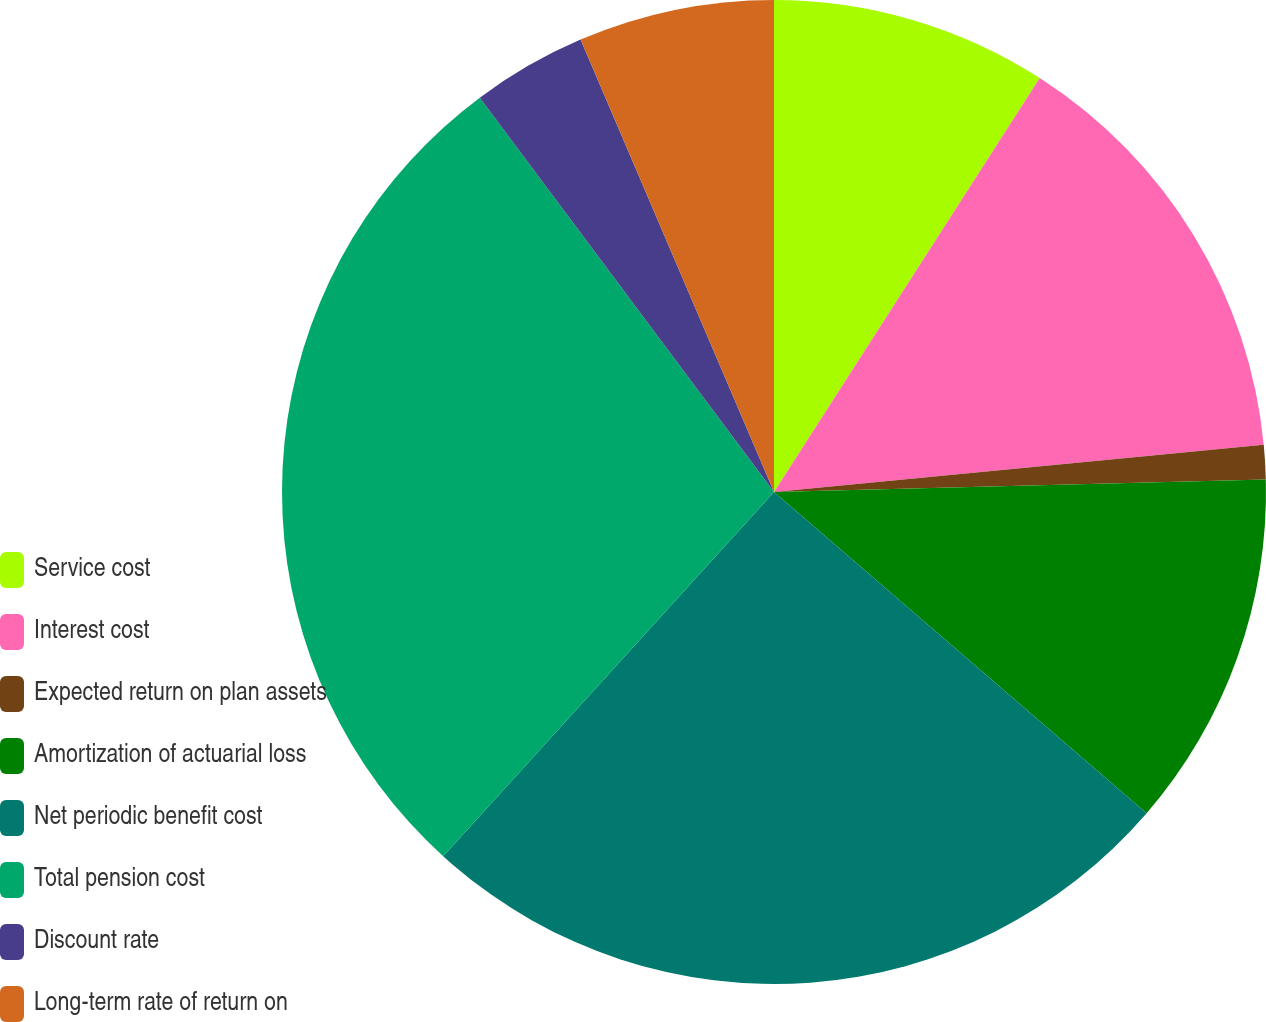Convert chart to OTSL. <chart><loc_0><loc_0><loc_500><loc_500><pie_chart><fcel>Service cost<fcel>Interest cost<fcel>Expected return on plan assets<fcel>Amortization of actuarial loss<fcel>Net periodic benefit cost<fcel>Total pension cost<fcel>Discount rate<fcel>Long-term rate of return on<nl><fcel>9.08%<fcel>14.39%<fcel>1.12%<fcel>11.73%<fcel>25.41%<fcel>28.06%<fcel>3.77%<fcel>6.43%<nl></chart> 